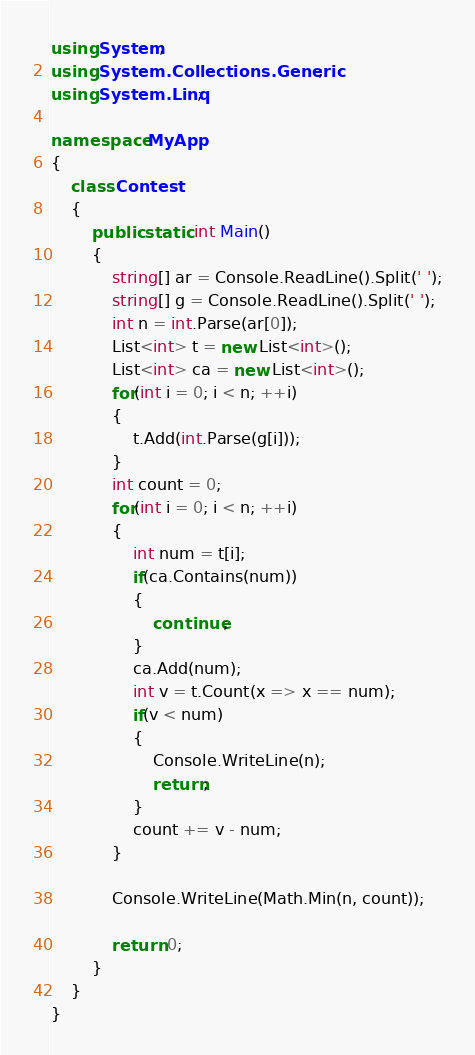Convert code to text. <code><loc_0><loc_0><loc_500><loc_500><_C#_>using System;
using System.Collections.Generic;
using System.Linq;

namespace MyApp
{
    class Contest
    {
        public static int Main()
        {
            string[] ar = Console.ReadLine().Split(' ');
            string[] g = Console.ReadLine().Split(' ');
            int n = int.Parse(ar[0]);
            List<int> t = new List<int>();
            List<int> ca = new List<int>();
            for(int i = 0; i < n; ++i)
            {
                t.Add(int.Parse(g[i]));
            }
            int count = 0;
            for(int i = 0; i < n; ++i)
            {
                int num = t[i];
                if(ca.Contains(num))
                {
                    continue;
                }
                ca.Add(num);
                int v = t.Count(x => x == num);
                if(v < num)
                {
                    Console.WriteLine(n);
                    return;
                }
                count += v - num;
            }

            Console.WriteLine(Math.Min(n, count));

            return 0;
        }
    }
}</code> 